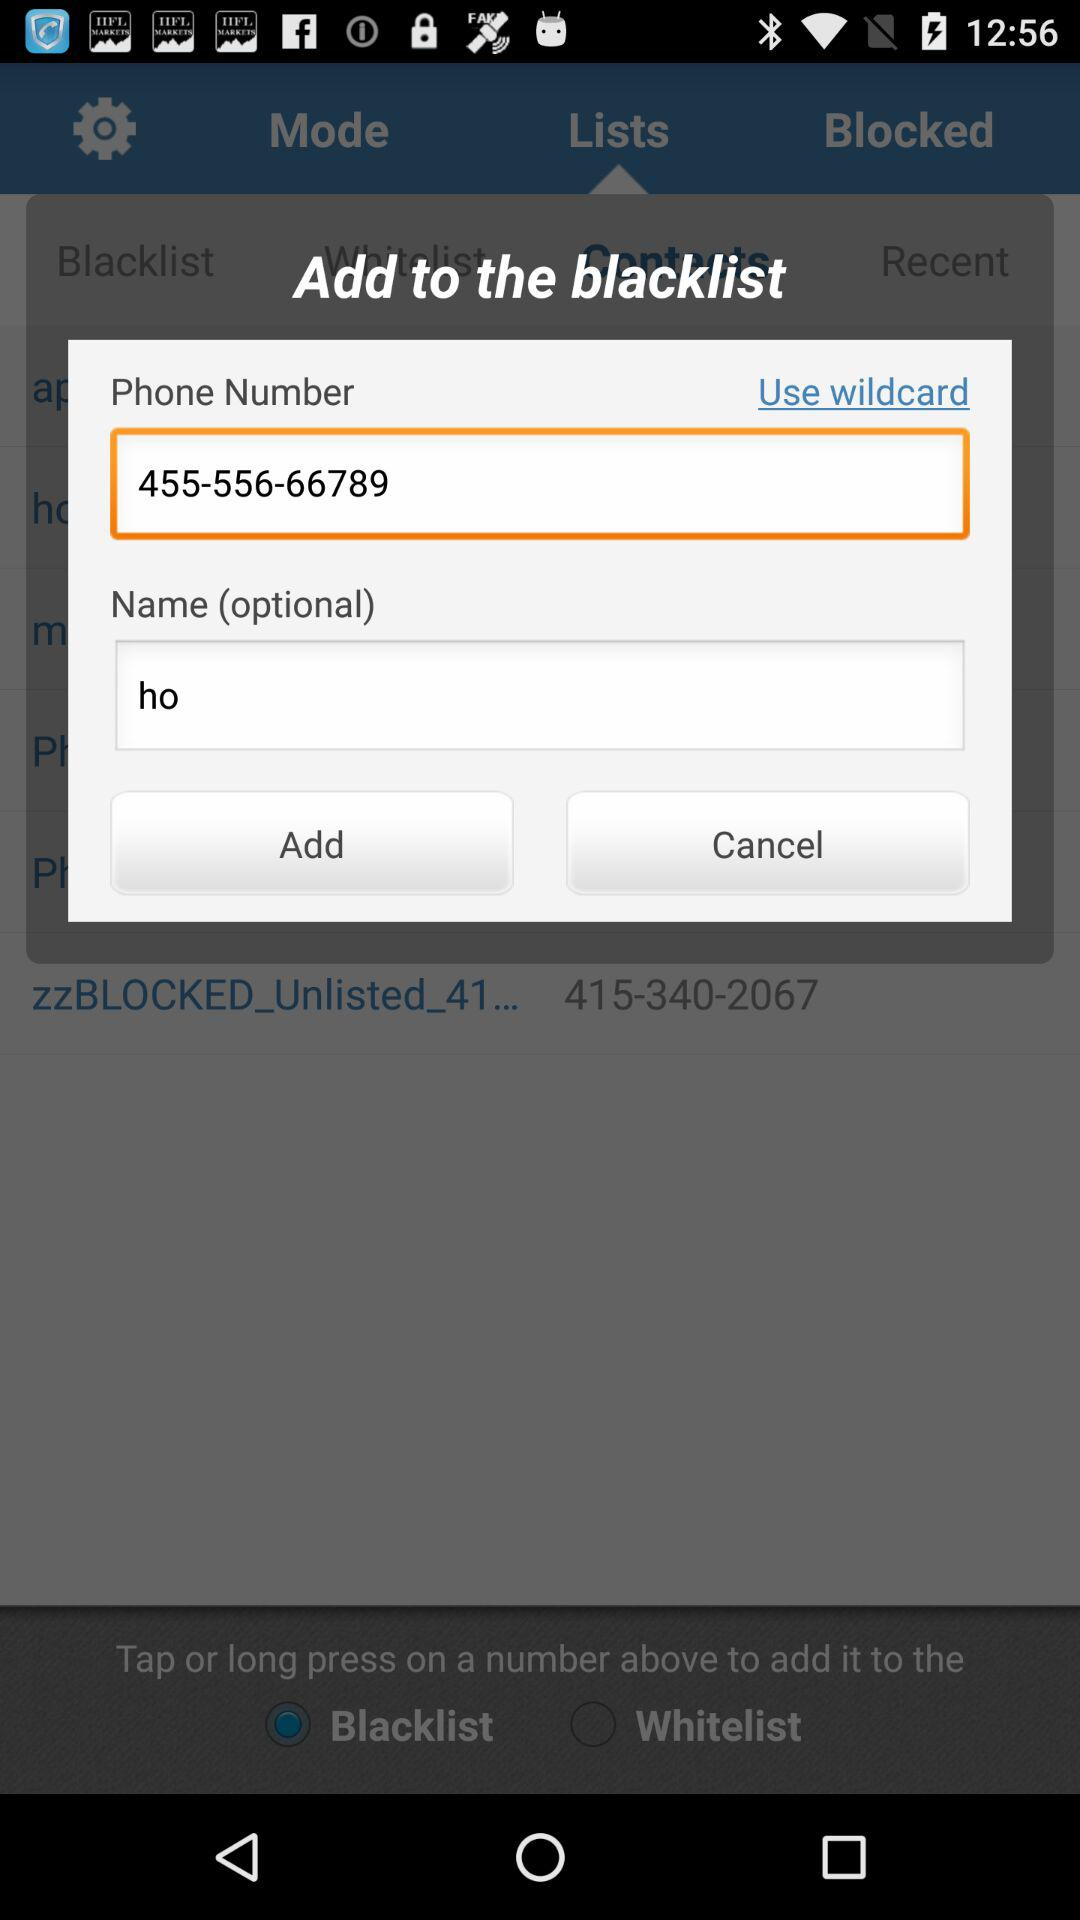What is the phone number? The phone number is 455-556-66789. 